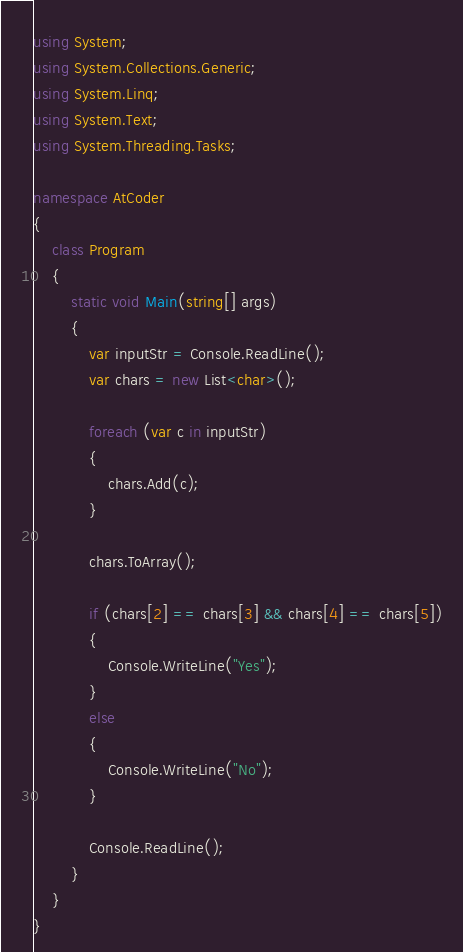Convert code to text. <code><loc_0><loc_0><loc_500><loc_500><_C#_>using System;
using System.Collections.Generic;
using System.Linq;
using System.Text;
using System.Threading.Tasks;

namespace AtCoder
{
    class Program
    {
        static void Main(string[] args)
        {
            var inputStr = Console.ReadLine();
            var chars = new List<char>();

            foreach (var c in inputStr)
            {
                chars.Add(c);
            }

            chars.ToArray();

            if (chars[2] == chars[3] && chars[4] == chars[5])
            {
                Console.WriteLine("Yes");
            }
            else
            {
                Console.WriteLine("No");
            }

            Console.ReadLine();
        }
    }
}
</code> 